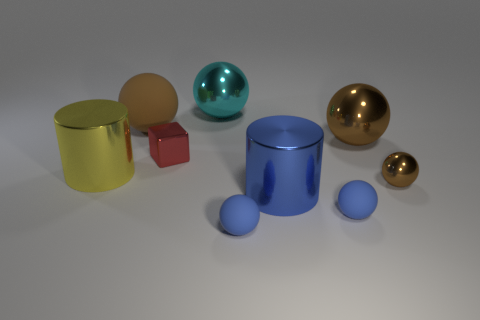Do the large rubber thing and the tiny metallic sphere have the same color?
Your answer should be very brief. Yes. There is a red block that is on the left side of the large cylinder that is in front of the metal ball in front of the red metal thing; what is it made of?
Your answer should be compact. Metal. Are there any brown shiny cubes that have the same size as the blue metallic object?
Offer a very short reply. No. The large yellow object has what shape?
Offer a terse response. Cylinder. How many spheres are either large yellow things or metallic objects?
Offer a very short reply. 3. Are there the same number of big blue metallic things that are behind the small red metal cube and matte things in front of the yellow object?
Make the answer very short. No. There is a brown sphere that is to the left of the small matte ball that is on the right side of the blue shiny thing; what number of large brown balls are on the right side of it?
Give a very brief answer. 1. What shape is the big metal object that is the same color as the big rubber thing?
Provide a succinct answer. Sphere. There is a tiny shiny sphere; does it have the same color as the rubber thing that is on the left side of the small red metallic cube?
Your answer should be very brief. Yes. Are there more balls that are in front of the red thing than tiny red objects?
Keep it short and to the point. Yes. 